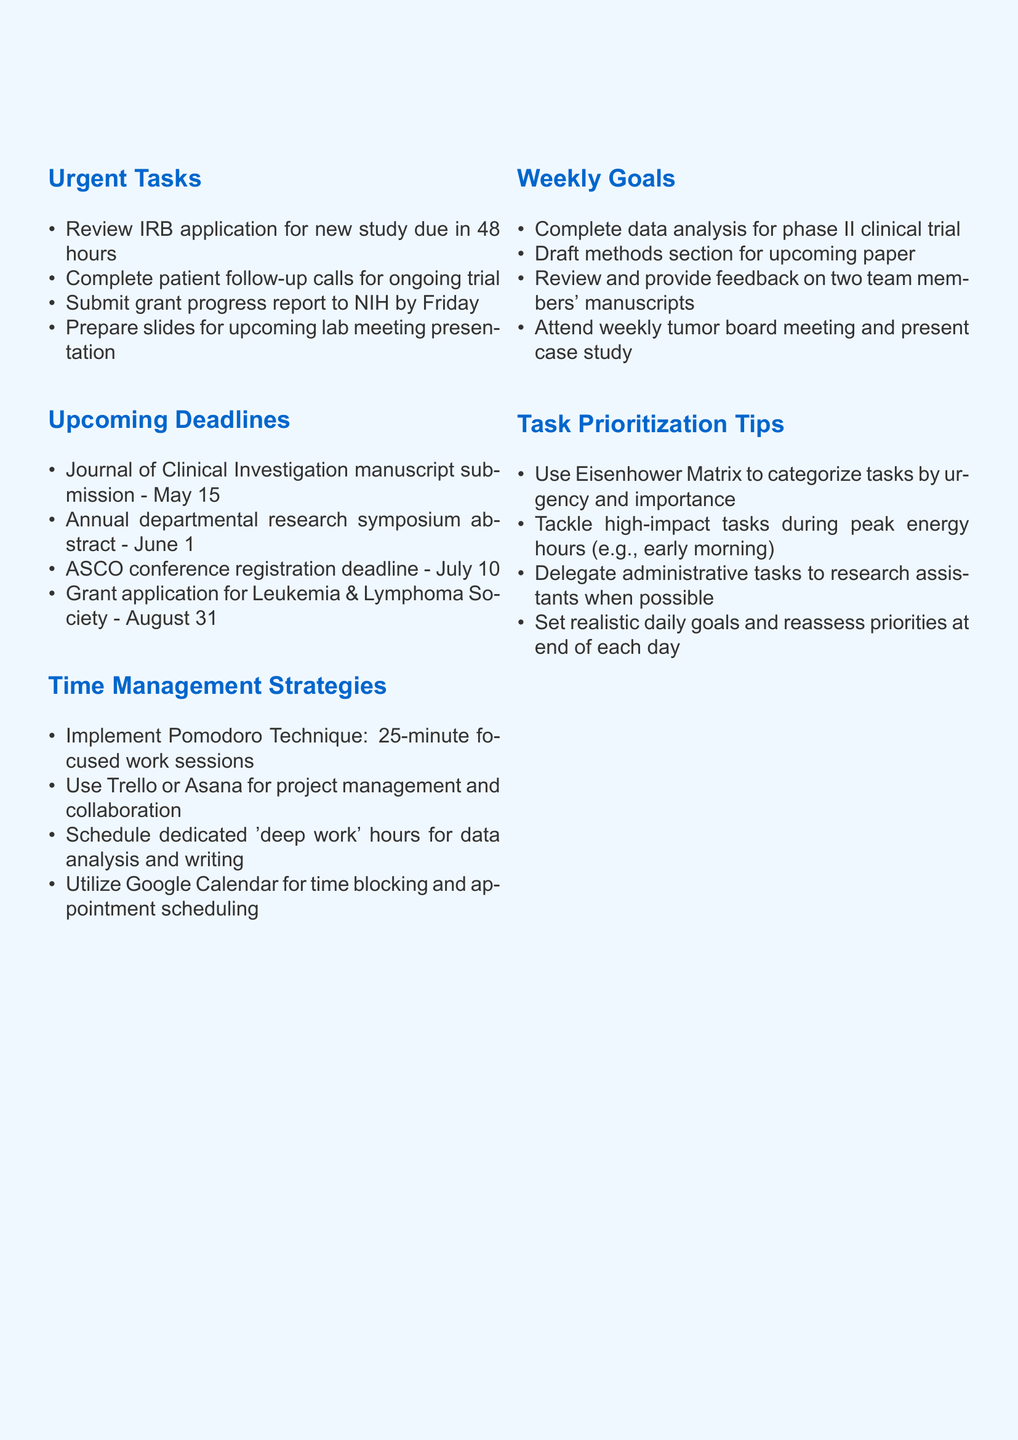What is the due date for the IRB application review? The due date is mentioned in the urgent tasks section as "due in 48 hours."
Answer: 48 hours What is the manuscript submission date for the Journal of Clinical Investigation? This date is listed under upcoming deadlines.
Answer: May 15 What task involves presenting at a weekly meeting? This task is specified in the weekly goals section of the document.
Answer: Weekly tumor board meeting Which time management strategy suggests using focused work sessions? It is mentioned in the time management strategies section as a technique.
Answer: Pomodoro Technique How many upcoming deadlines are listed in the document? The document lists four items under the upcoming deadlines section.
Answer: 4 What technique is suggested to categorize tasks? This technique is discussed in the task prioritization tips section.
Answer: Eisenhower Matrix When is the registration deadline for the ASCO conference? This date is found in the upcoming deadlines section.
Answer: July 10 What is advised to be done during peak energy hours? This recommendation is found in the task prioritization tips section.
Answer: High-impact tasks Which project management tools are recommended? The document lists tools in the time management strategies section.
Answer: Trello or Asana 